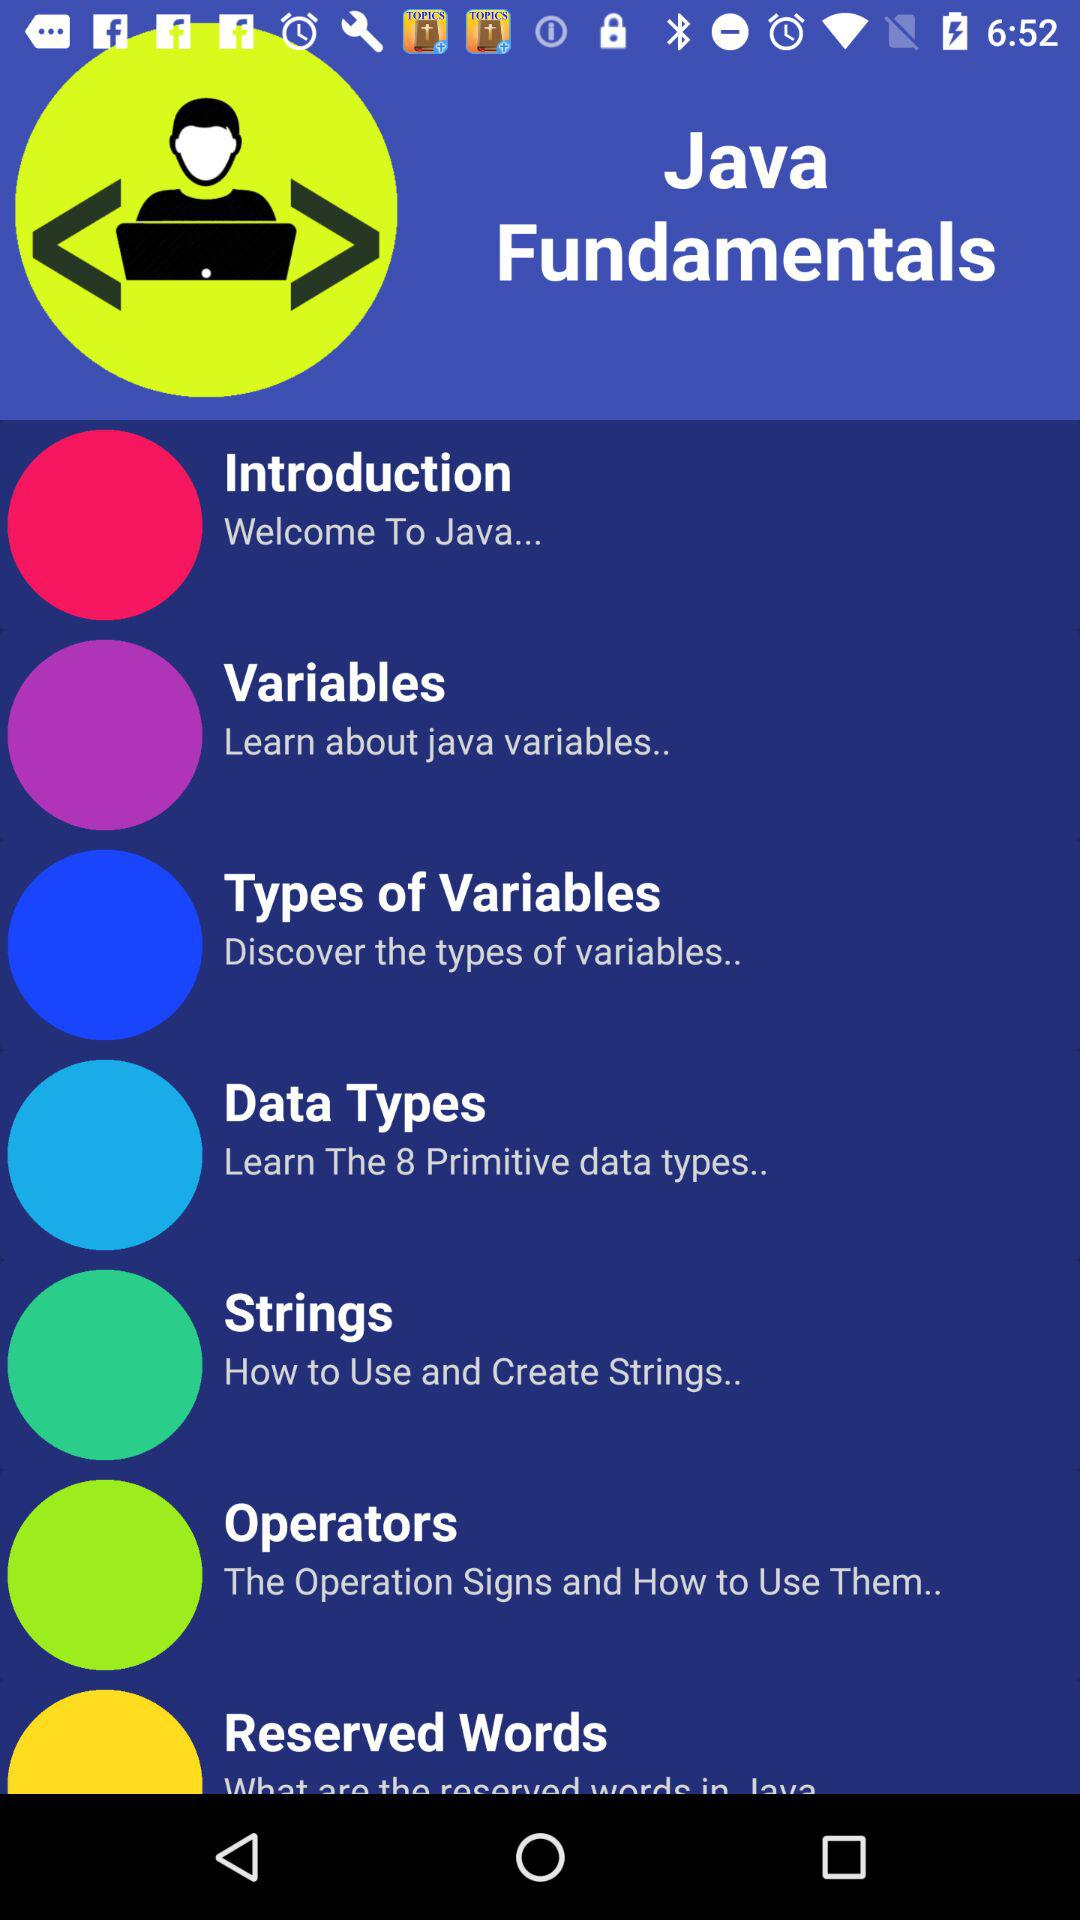What is the course name? The course name is "Java Fundamentals". 